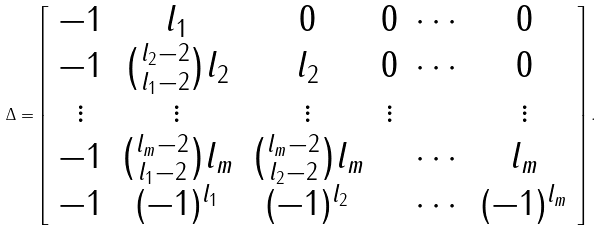Convert formula to latex. <formula><loc_0><loc_0><loc_500><loc_500>\Delta = \left [ \begin{array} { c c c c c c } - 1 & l _ { 1 } & 0 & 0 & \cdots & 0 \\ - 1 & \binom { l _ { 2 } - 2 } { l _ { 1 } - 2 } l _ { 2 } & l _ { 2 } & 0 & \cdots & 0 \\ \vdots & \vdots & \vdots & \vdots & & \vdots \\ - 1 & \binom { l _ { m } - 2 } { l _ { 1 } - 2 } l _ { m } & \binom { l _ { m } - 2 } { l _ { 2 } - 2 } l _ { m } & & \cdots & l _ { m } \\ - 1 & ( - 1 ) ^ { l _ { 1 } } & ( - 1 ) ^ { l _ { 2 } } & & \cdots & ( - 1 ) ^ { l _ { m } } \end{array} \right ] .</formula> 